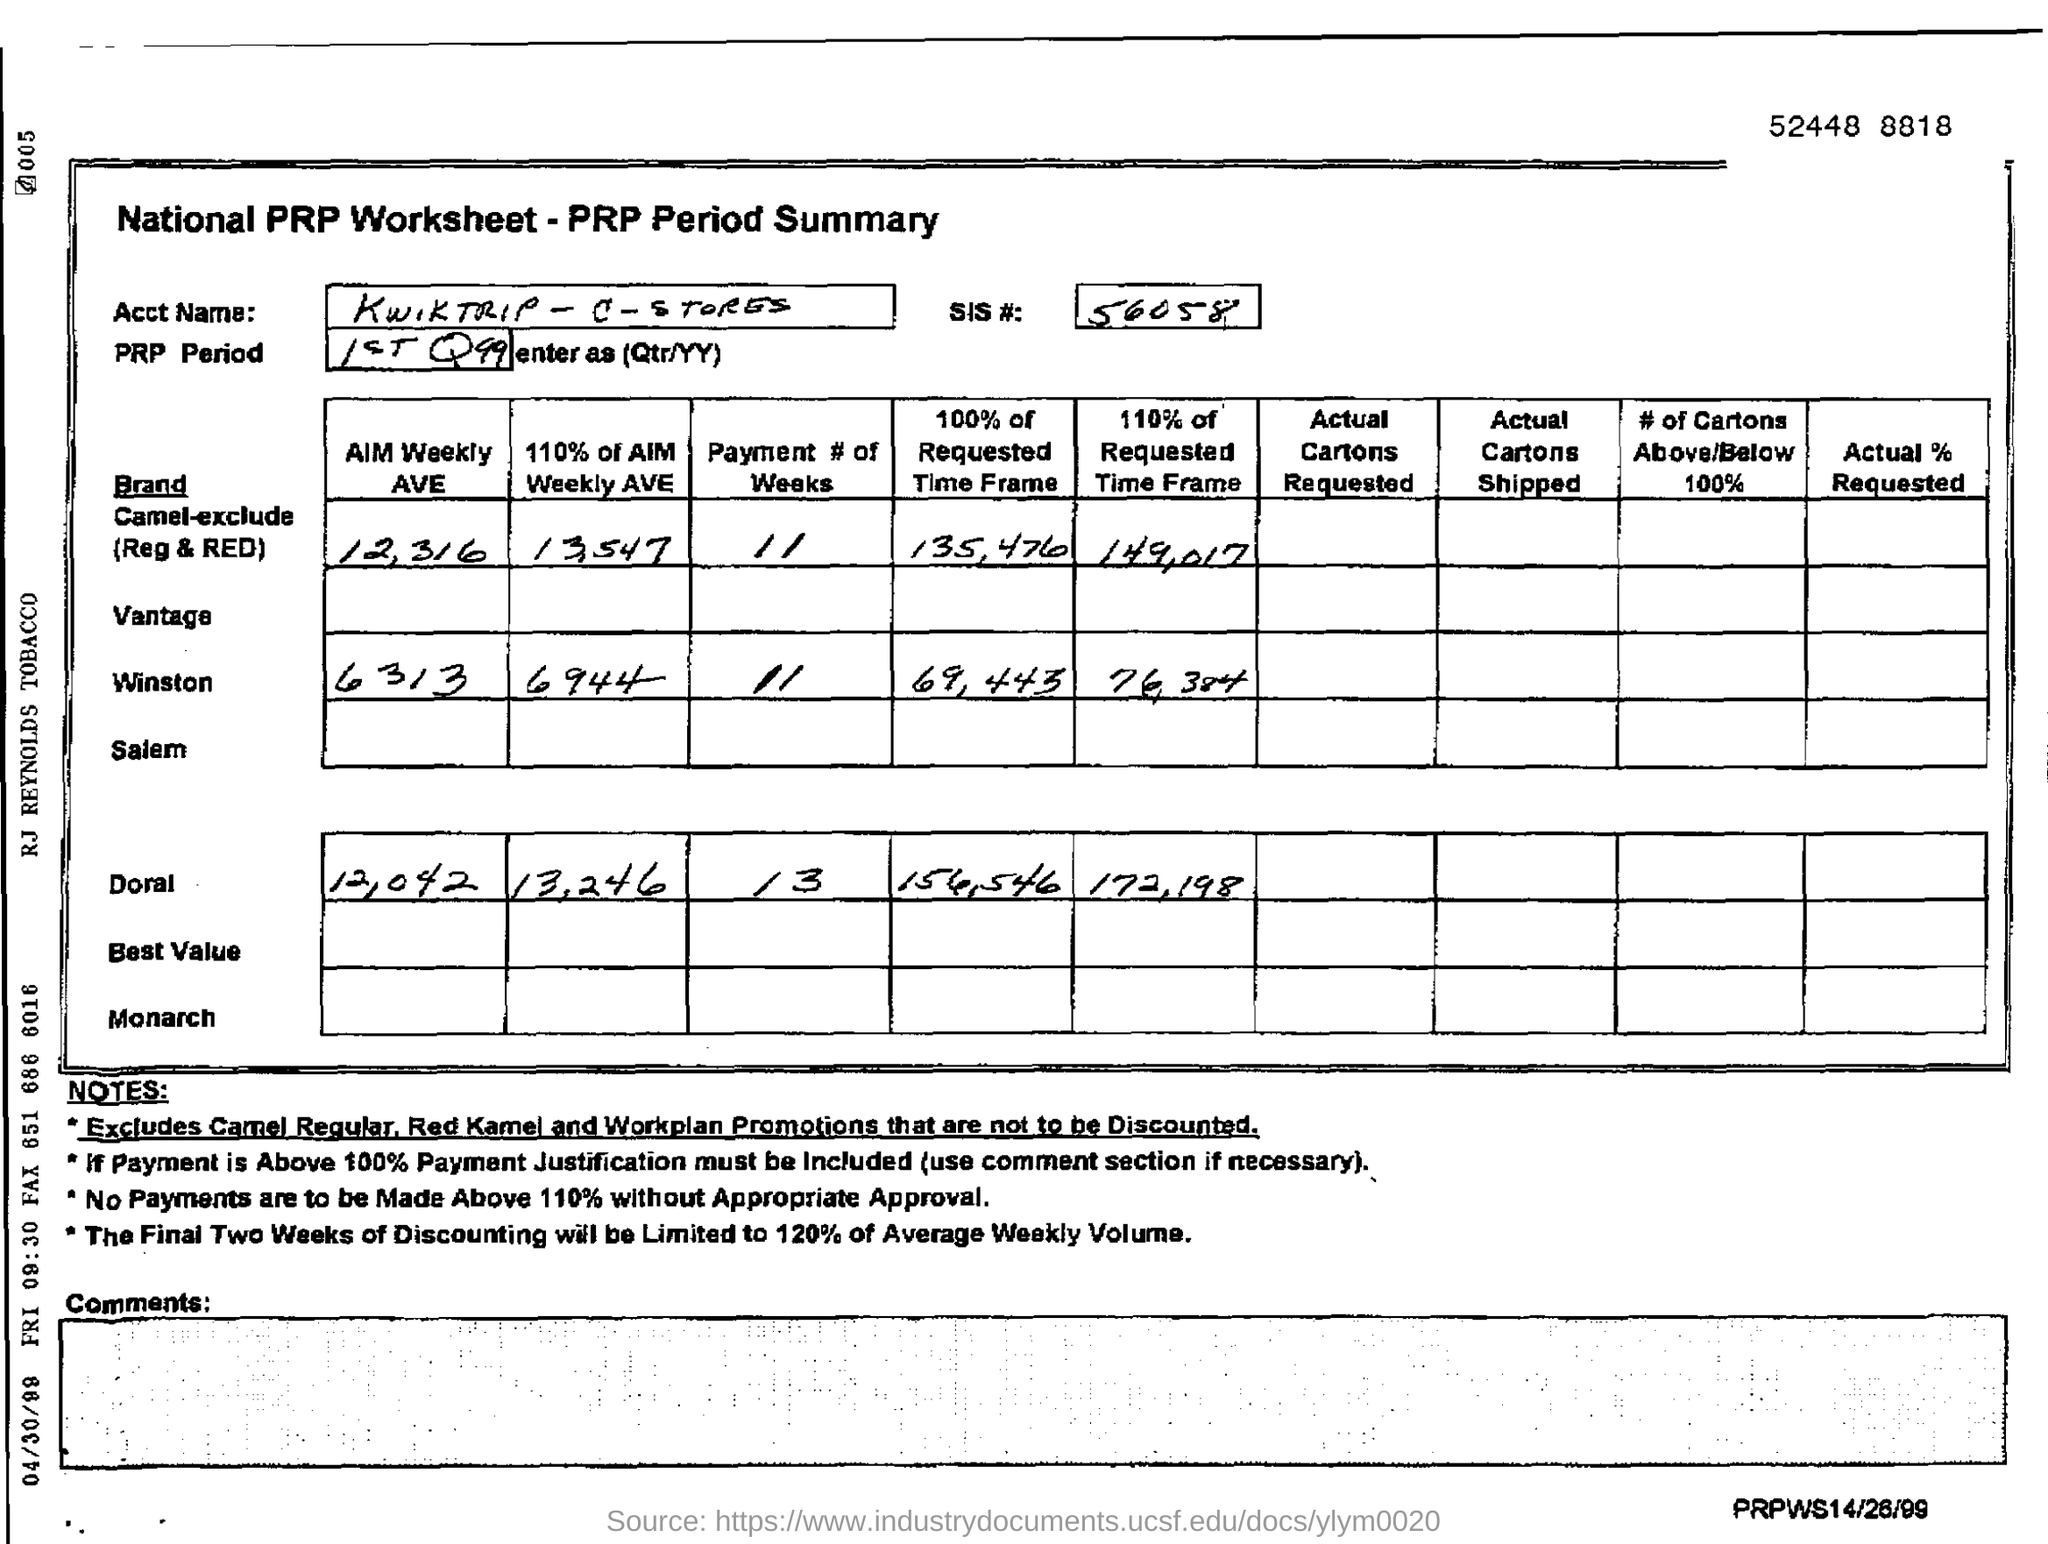Mention a couple of crucial points in this snapshot. The SIS# mentioned in the form is 56058. The digit displayed in the top right corner of the number 52448 is 5. 